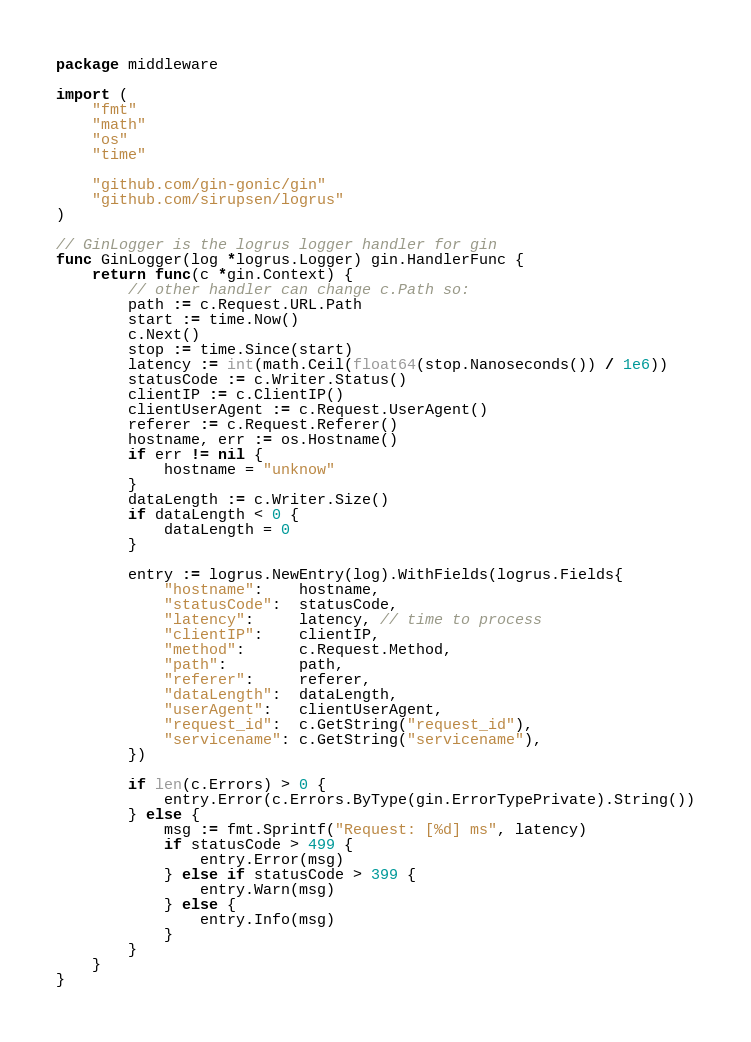Convert code to text. <code><loc_0><loc_0><loc_500><loc_500><_Go_>package middleware

import (
	"fmt"
	"math"
	"os"
	"time"

	"github.com/gin-gonic/gin"
	"github.com/sirupsen/logrus"
)

// GinLogger is the logrus logger handler for gin
func GinLogger(log *logrus.Logger) gin.HandlerFunc {
	return func(c *gin.Context) {
		// other handler can change c.Path so:
		path := c.Request.URL.Path
		start := time.Now()
		c.Next()
		stop := time.Since(start)
		latency := int(math.Ceil(float64(stop.Nanoseconds()) / 1e6))
		statusCode := c.Writer.Status()
		clientIP := c.ClientIP()
		clientUserAgent := c.Request.UserAgent()
		referer := c.Request.Referer()
		hostname, err := os.Hostname()
		if err != nil {
			hostname = "unknow"
		}
		dataLength := c.Writer.Size()
		if dataLength < 0 {
			dataLength = 0
		}

		entry := logrus.NewEntry(log).WithFields(logrus.Fields{
			"hostname":    hostname,
			"statusCode":  statusCode,
			"latency":     latency, // time to process
			"clientIP":    clientIP,
			"method":      c.Request.Method,
			"path":        path,
			"referer":     referer,
			"dataLength":  dataLength,
			"userAgent":   clientUserAgent,
			"request_id":  c.GetString("request_id"),
			"servicename": c.GetString("servicename"),
		})

		if len(c.Errors) > 0 {
			entry.Error(c.Errors.ByType(gin.ErrorTypePrivate).String())
		} else {
			msg := fmt.Sprintf("Request: [%d] ms", latency)
			if statusCode > 499 {
				entry.Error(msg)
			} else if statusCode > 399 {
				entry.Warn(msg)
			} else {
				entry.Info(msg)
			}
		}
	}
}
</code> 